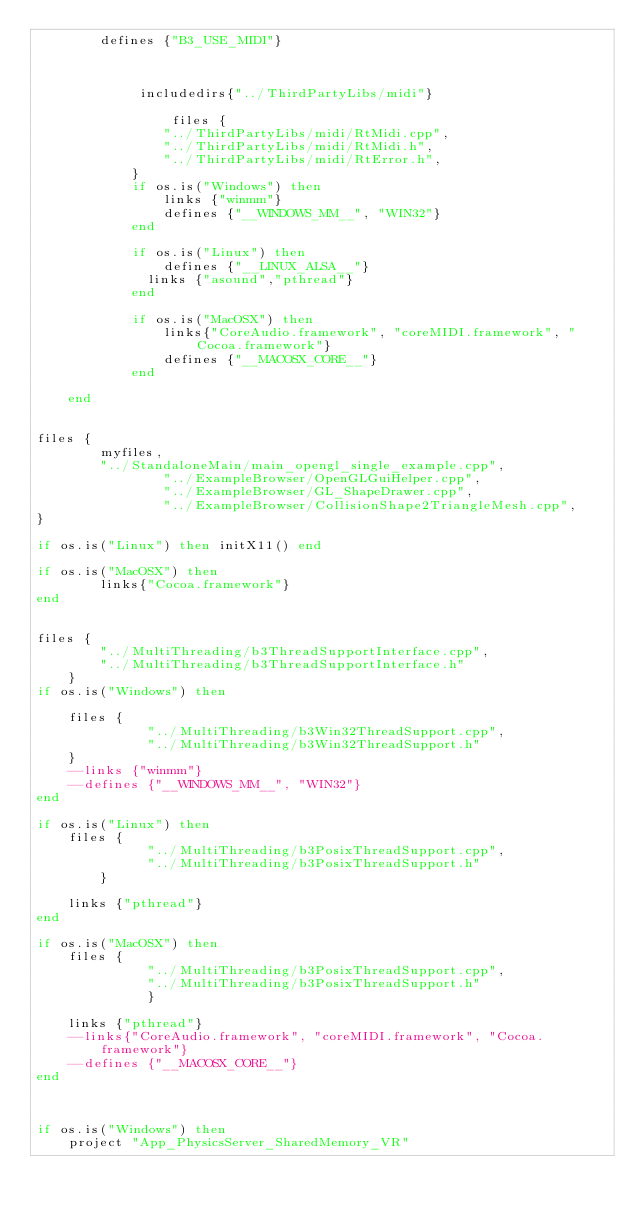<code> <loc_0><loc_0><loc_500><loc_500><_Lua_>		defines {"B3_USE_MIDI"}

			
					
			 includedirs{"../ThirdPartyLibs/midi"}
			
				 files {
	        	"../ThirdPartyLibs/midi/RtMidi.cpp",
	        	"../ThirdPartyLibs/midi/RtMidi.h",
	        	"../ThirdPartyLibs/midi/RtError.h",
        	} 
			if os.is("Windows") then
				links {"winmm"}
				defines {"__WINDOWS_MM__", "WIN32"}
			end

			if os.is("Linux") then 
				defines {"__LINUX_ALSA__"}
			  links {"asound","pthread"}
			end

			if os.is("MacOSX") then
				links{"CoreAudio.framework", "coreMIDI.framework", "Cocoa.framework"}
				defines {"__MACOSX_CORE__"}
			end
		
	end


files {
        myfiles,
        "../StandaloneMain/main_opengl_single_example.cpp",
				"../ExampleBrowser/OpenGLGuiHelper.cpp",
				"../ExampleBrowser/GL_ShapeDrawer.cpp",
				"../ExampleBrowser/CollisionShape2TriangleMesh.cpp",
}

if os.is("Linux") then initX11() end

if os.is("MacOSX") then
        links{"Cocoa.framework"}
end


files {
		"../MultiThreading/b3ThreadSupportInterface.cpp",
		"../MultiThreading/b3ThreadSupportInterface.h"
	}
if os.is("Windows") then

	files {
              "../MultiThreading/b3Win32ThreadSupport.cpp",  
              "../MultiThreading/b3Win32ThreadSupport.h" 
	}
	--links {"winmm"}
	--defines {"__WINDOWS_MM__", "WIN32"}
end

if os.is("Linux") then 
	files {
              "../MultiThreading/b3PosixThreadSupport.cpp",  
              "../MultiThreading/b3PosixThreadSupport.h"    
      	}

	links {"pthread"}
end

if os.is("MacOSX") then
	files {
              "../MultiThreading/b3PosixThreadSupport.cpp",
              "../MultiThreading/b3PosixThreadSupport.h"    
              }

	links {"pthread"}
	--links{"CoreAudio.framework", "coreMIDI.framework", "Cocoa.framework"}
	--defines {"__MACOSX_CORE__"}
end



if os.is("Windows") then 
	project "App_PhysicsServer_SharedMemory_VR"</code> 